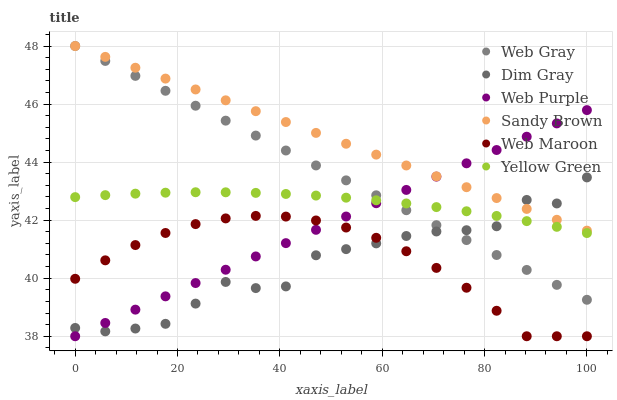Does Dim Gray have the minimum area under the curve?
Answer yes or no. Yes. Does Sandy Brown have the maximum area under the curve?
Answer yes or no. Yes. Does Yellow Green have the minimum area under the curve?
Answer yes or no. No. Does Yellow Green have the maximum area under the curve?
Answer yes or no. No. Is Web Purple the smoothest?
Answer yes or no. Yes. Is Dim Gray the roughest?
Answer yes or no. Yes. Is Yellow Green the smoothest?
Answer yes or no. No. Is Yellow Green the roughest?
Answer yes or no. No. Does Web Maroon have the lowest value?
Answer yes or no. Yes. Does Yellow Green have the lowest value?
Answer yes or no. No. Does Sandy Brown have the highest value?
Answer yes or no. Yes. Does Yellow Green have the highest value?
Answer yes or no. No. Is Yellow Green less than Sandy Brown?
Answer yes or no. Yes. Is Web Gray greater than Web Maroon?
Answer yes or no. Yes. Does Yellow Green intersect Web Gray?
Answer yes or no. Yes. Is Yellow Green less than Web Gray?
Answer yes or no. No. Is Yellow Green greater than Web Gray?
Answer yes or no. No. Does Yellow Green intersect Sandy Brown?
Answer yes or no. No. 